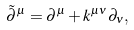Convert formula to latex. <formula><loc_0><loc_0><loc_500><loc_500>\tilde { \partial } ^ { \mu } = \partial ^ { \mu } + k ^ { \mu \nu } \partial _ { \nu } ,</formula> 